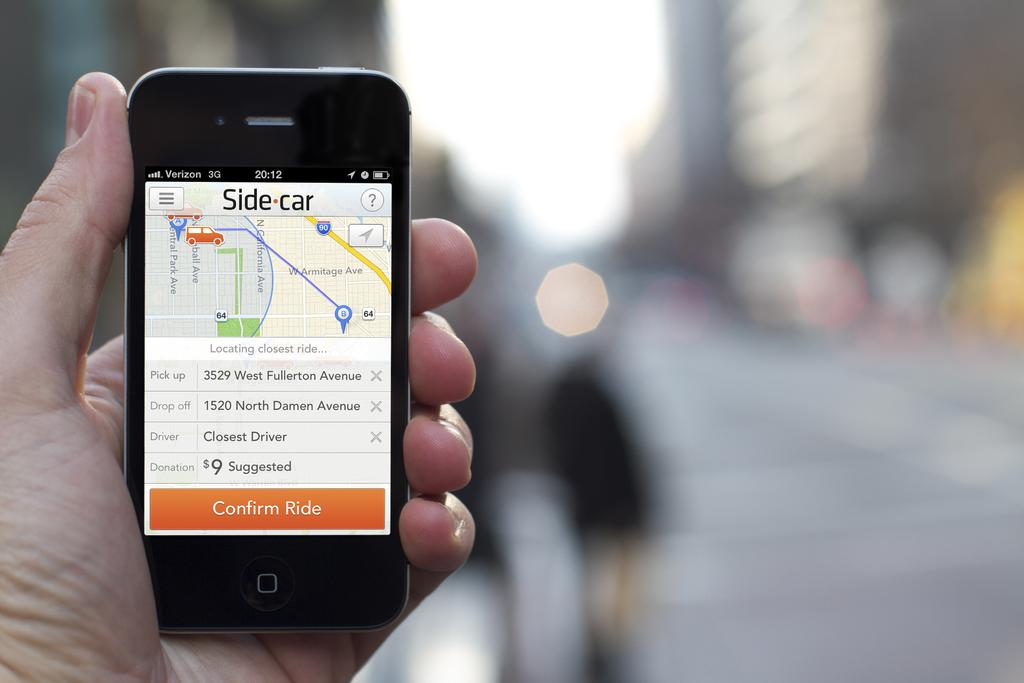<image>
Give a short and clear explanation of the subsequent image. A hand holding a phone that is waiting for a Side car. 